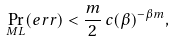<formula> <loc_0><loc_0><loc_500><loc_500>\Pr _ { M L } ( e r r ) < \frac { m } { 2 } \, c ( \beta ) ^ { - \beta m } ,</formula> 